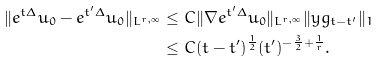<formula> <loc_0><loc_0><loc_500><loc_500>\| e ^ { t \Delta } u _ { 0 } - e ^ { t ^ { \prime } \Delta } u _ { 0 } \| _ { L ^ { r , \infty } } & \leq C \| \nabla e ^ { t ^ { \prime } \Delta } u _ { 0 } \| _ { L ^ { r , \infty } } \| y g _ { t - t ^ { \prime } } \| _ { 1 } \\ & \leq C ( t - t ^ { \prime } ) ^ { \frac { 1 } { 2 } } ( t ^ { \prime } ) ^ { - \frac { 3 } { 2 } + \frac { 1 } { r } } .</formula> 